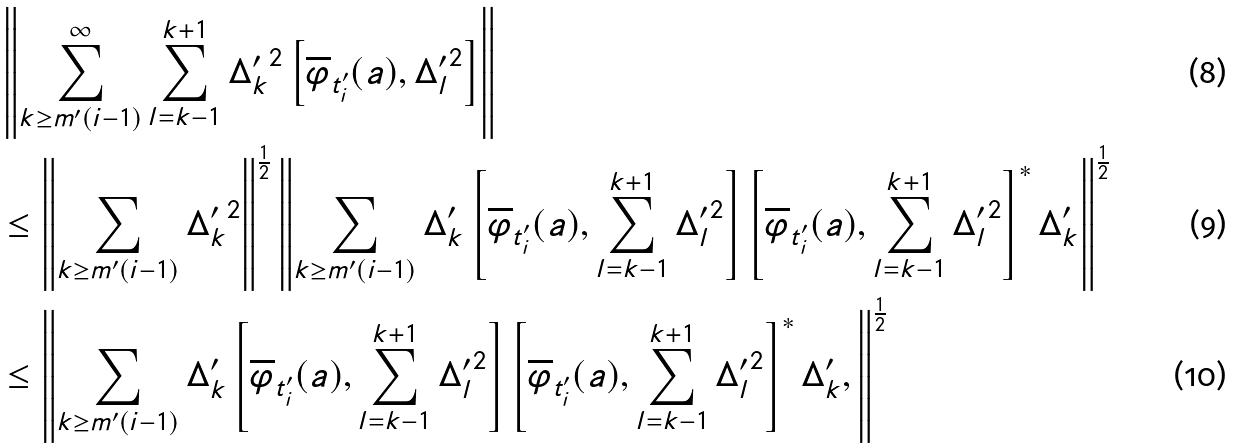<formula> <loc_0><loc_0><loc_500><loc_500>& \left \| \sum _ { k \geq m ^ { \prime } ( i - 1 ) } ^ { \infty } \sum _ { l = k - 1 } ^ { k + 1 } { \Delta ^ { \prime } _ { k } } ^ { 2 } \left [ \overline { \varphi } _ { t ^ { \prime } _ { i } } ( a ) , { \Delta ^ { \prime } _ { l } } ^ { 2 } \right ] \right \| \\ & \leq \left \| \sum _ { k \geq m ^ { \prime } ( i - 1 ) } { \Delta ^ { \prime } _ { k } } ^ { 2 } \right \| ^ { \frac { 1 } { 2 } } \left \| \sum _ { k \geq m ^ { \prime } ( i - 1 ) } \Delta ^ { \prime } _ { k } \left [ \overline { \varphi } _ { t ^ { \prime } _ { i } } ( a ) , \sum _ { l = k - 1 } ^ { k + 1 } { \Delta ^ { \prime } _ { l } } ^ { 2 } \right ] \left [ \overline { \varphi } _ { t ^ { \prime } _ { i } } ( a ) , \sum _ { l = k - 1 } ^ { k + 1 } { \Delta ^ { \prime } _ { l } } ^ { 2 } \right ] ^ { * } \Delta ^ { \prime } _ { k } \right \| ^ { \frac { 1 } { 2 } } \\ & \leq \left \| \sum _ { k \geq m ^ { \prime } ( i - 1 ) } \Delta ^ { \prime } _ { k } \left [ \overline { \varphi } _ { t ^ { \prime } _ { i } } ( a ) , \sum _ { l = k - 1 } ^ { k + 1 } { \Delta ^ { \prime } _ { l } } ^ { 2 } \right ] \left [ \overline { \varphi } _ { t ^ { \prime } _ { i } } ( a ) , \sum _ { l = k - 1 } ^ { k + 1 } { \Delta ^ { \prime } _ { l } } ^ { 2 } \right ] ^ { * } \Delta ^ { \prime } _ { k } , \right \| ^ { \frac { 1 } { 2 } }</formula> 